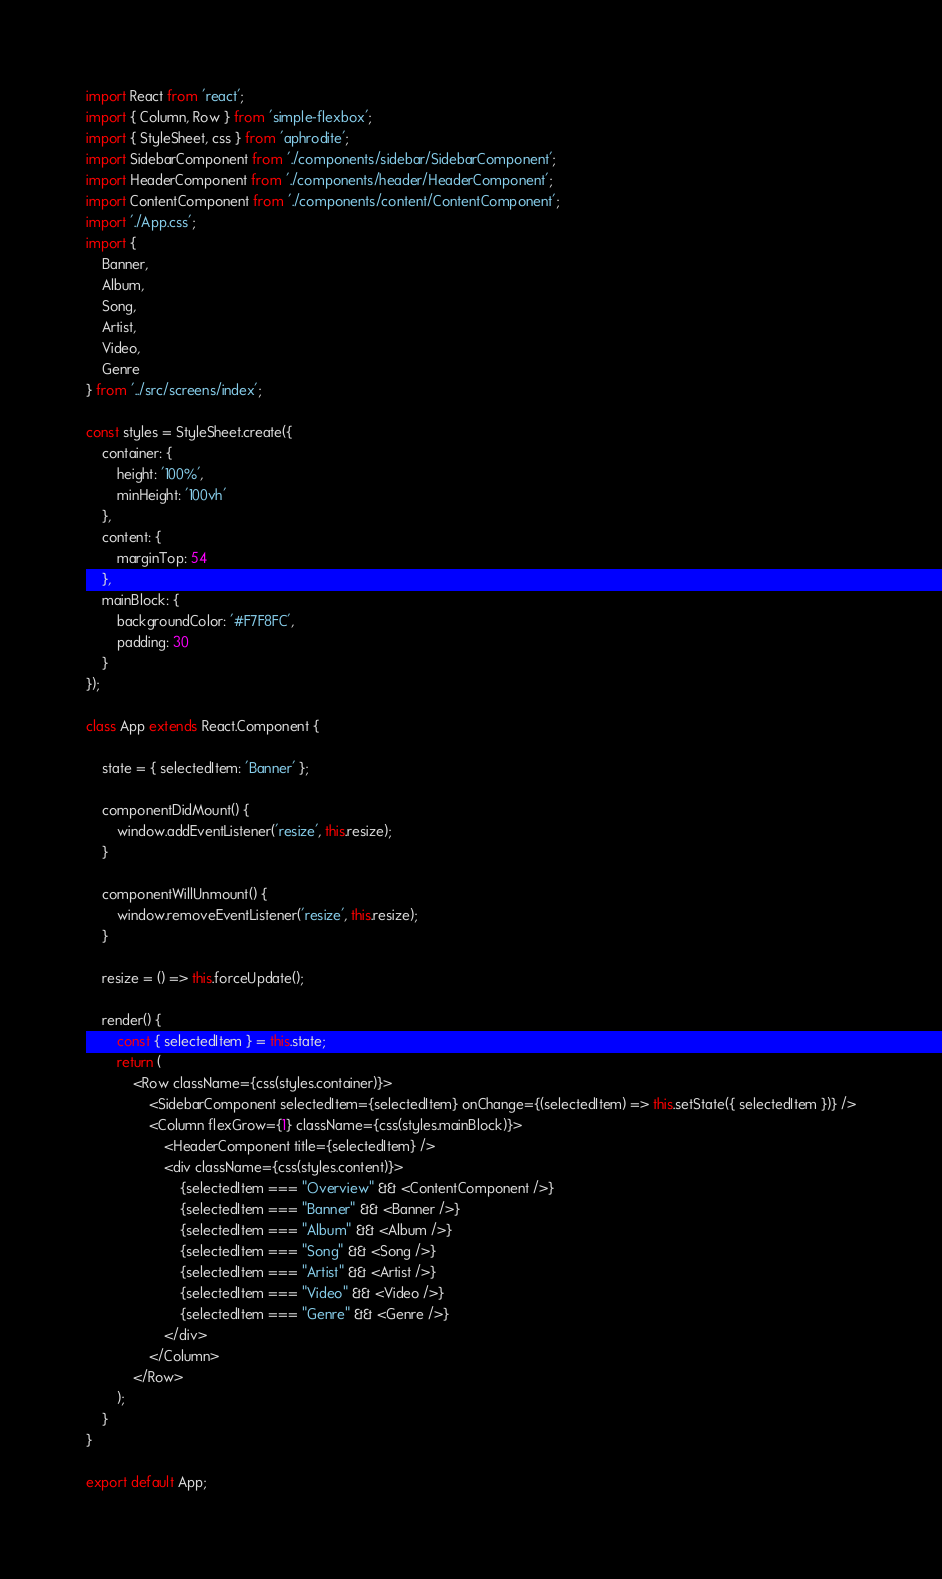Convert code to text. <code><loc_0><loc_0><loc_500><loc_500><_JavaScript_>import React from 'react';
import { Column, Row } from 'simple-flexbox';
import { StyleSheet, css } from 'aphrodite';
import SidebarComponent from './components/sidebar/SidebarComponent';
import HeaderComponent from './components/header/HeaderComponent';
import ContentComponent from './components/content/ContentComponent';
import './App.css';
import {
    Banner,
    Album,
    Song,
    Artist,
    Video,
    Genre
} from '../src/screens/index';

const styles = StyleSheet.create({
    container: {
        height: '100%',
        minHeight: '100vh'
    },
    content: {
        marginTop: 54
    },
    mainBlock: {
        backgroundColor: '#F7F8FC',
        padding: 30
    }
});

class App extends React.Component {

    state = { selectedItem: 'Banner' };

    componentDidMount() {
        window.addEventListener('resize', this.resize);
    }

    componentWillUnmount() {
        window.removeEventListener('resize', this.resize);
    }

    resize = () => this.forceUpdate();

    render() {
        const { selectedItem } = this.state;
        return (
            <Row className={css(styles.container)}>
                <SidebarComponent selectedItem={selectedItem} onChange={(selectedItem) => this.setState({ selectedItem })} />
                <Column flexGrow={1} className={css(styles.mainBlock)}>
                    <HeaderComponent title={selectedItem} />
                    <div className={css(styles.content)}>
                        {selectedItem === "Overview" && <ContentComponent />}
                        {selectedItem === "Banner" && <Banner />}
                        {selectedItem === "Album" && <Album />}
                        {selectedItem === "Song" && <Song />}
                        {selectedItem === "Artist" && <Artist />}
                        {selectedItem === "Video" && <Video />}
                        {selectedItem === "Genre" && <Genre />}
                    </div>
                </Column>
            </Row>
        );
    }
}

export default App;
</code> 